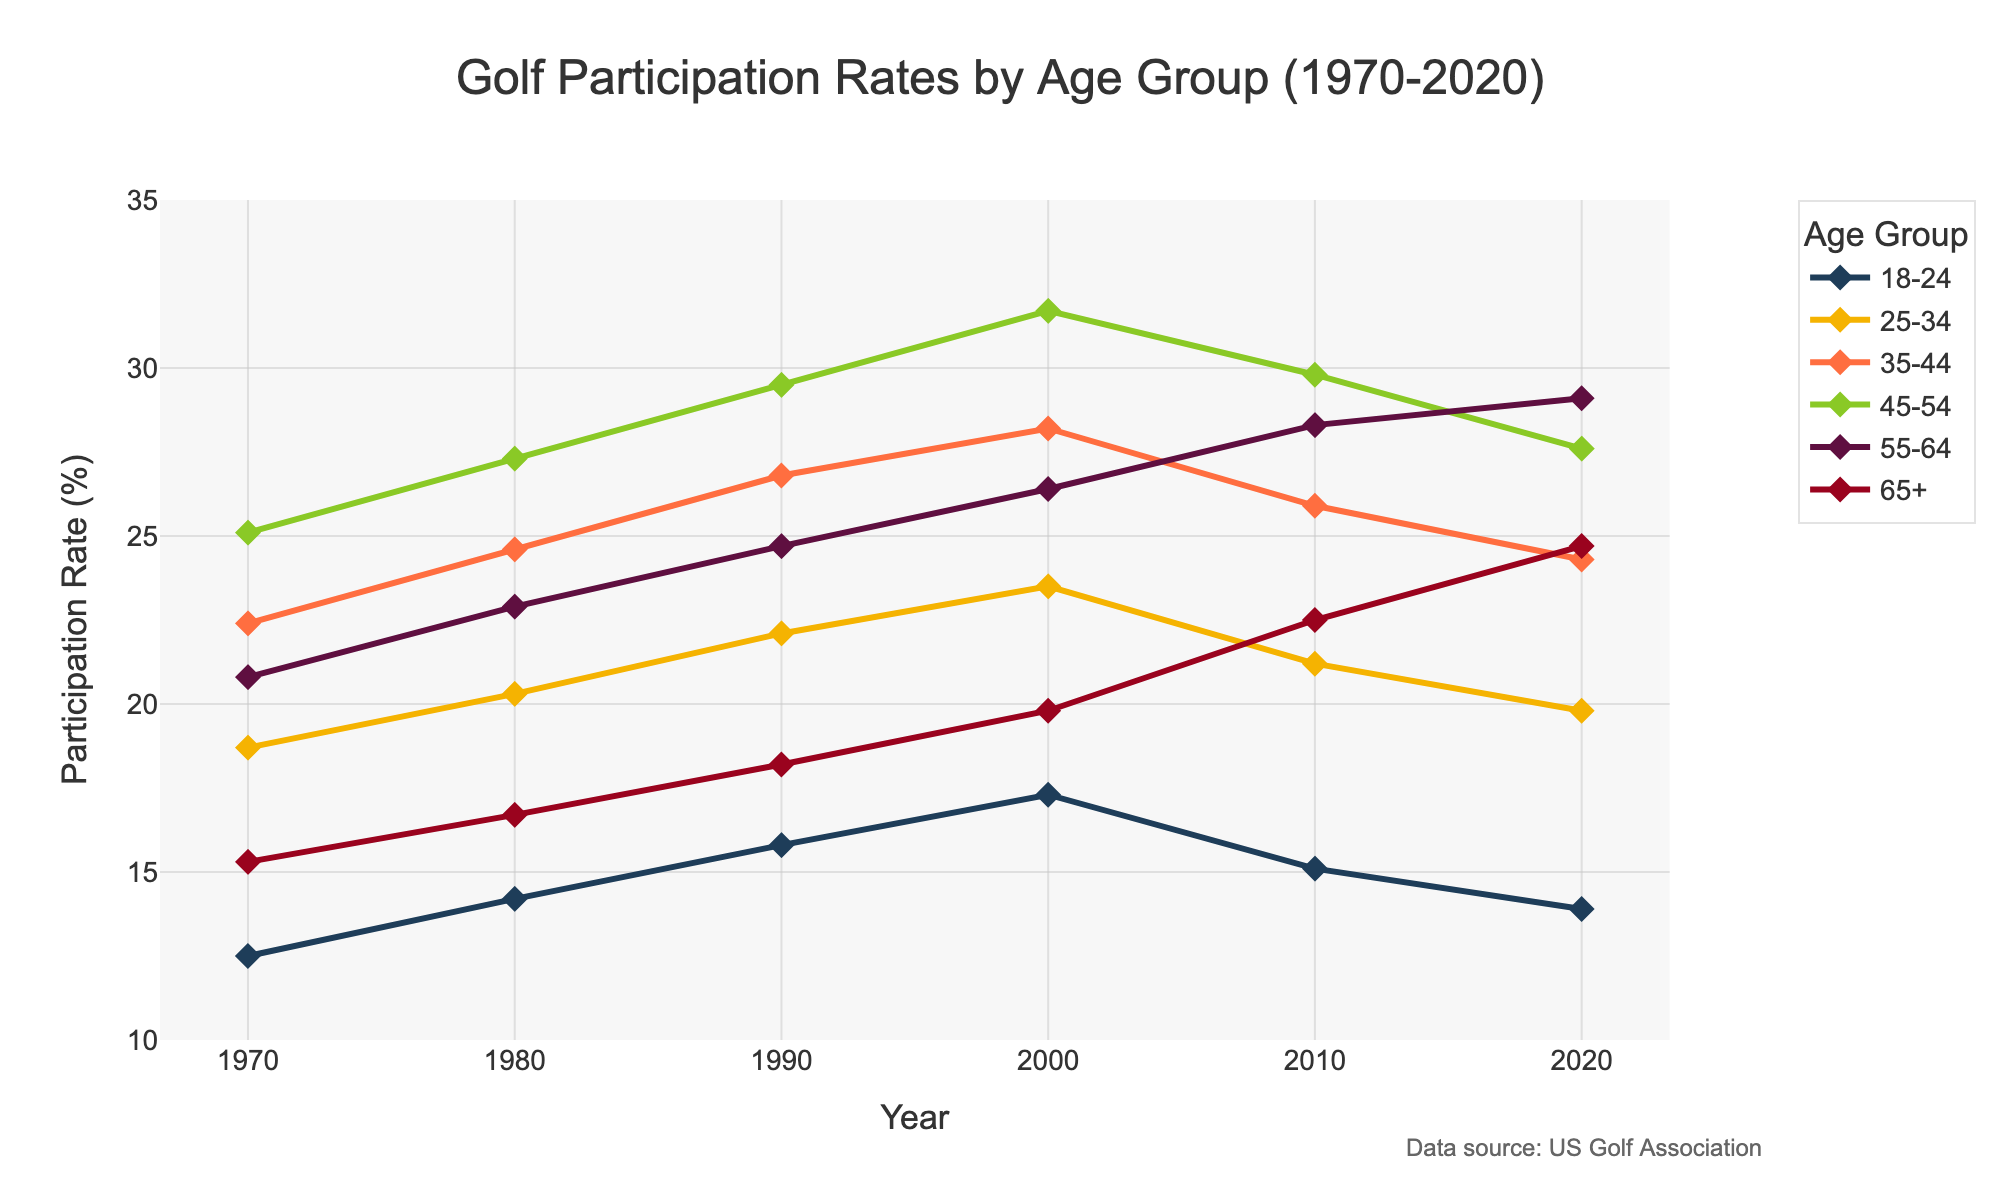What age group had the highest participation rate in 2020? Look at the graph for the point labeled 2020. Identify the line that reaches the highest value on the y-axis for that point.
Answer: 55-64 Which age group saw the largest increase in participation rate from 1970 to 2020? Compare the increase for each age group by subtracting the 1970 value from the 2020 value for each age group. The age group with the highest difference is the answer.
Answer: 65+ Between which decades did the 45-54 age group see the most significant increase in participation rate? Look at the plot for the 45-54 age group and find the years between which the value change is the highest. Subtract adjacent decade values to find the largest increase.
Answer: 1970-1980 What was the average participation rate for the 35-44 age group over the decades shown? Add the participation rates for the 35-44 age group across all decades and divide the sum by the number of decades (6).
Answer: (22.4 + 24.6 + 26.8 + 28.2 + 25.9 + 24.3) / 6 = 25.37 How does the participation rate of the 18-24 age group in 2000 compare to the 65+ age group in the same year? Find the values for both age groups in the year 2000 and compare them.
Answer: 18-24 had 17.3%, 65+ had 19.8%, so 65+ was higher Which two age groups had the closest participation rates in 2010? Compare the participation rates for all age groups in 2010 and find the pair with the smallest difference between their values.
Answer: 18-24 and 65+ What's the overall trend for the 55-64 age group's participation rate from 1970 to 2020? Observe the line plot for the 55-64 age group and describe whether it is generally increasing, decreasing, or remaining constant over time.
Answer: Increasing In what decade did the 25-34 age group reach its peak participation rate? Find the highest value for the 25-34 age group and identify the corresponding decade.
Answer: 2000 By how much did the participation rate of the 18-24 age group change from 2000 to 2020? Subtract the 2020 participation rate from the 2000 participation rate for the 18-24 age group.
Answer: 17.3 - 13.9 = 3.4 Which age group had a participation rate below 20% in 1980? Look at the values for each age group in the year 1980 and identify the one below 20%.
Answer: 18-24 